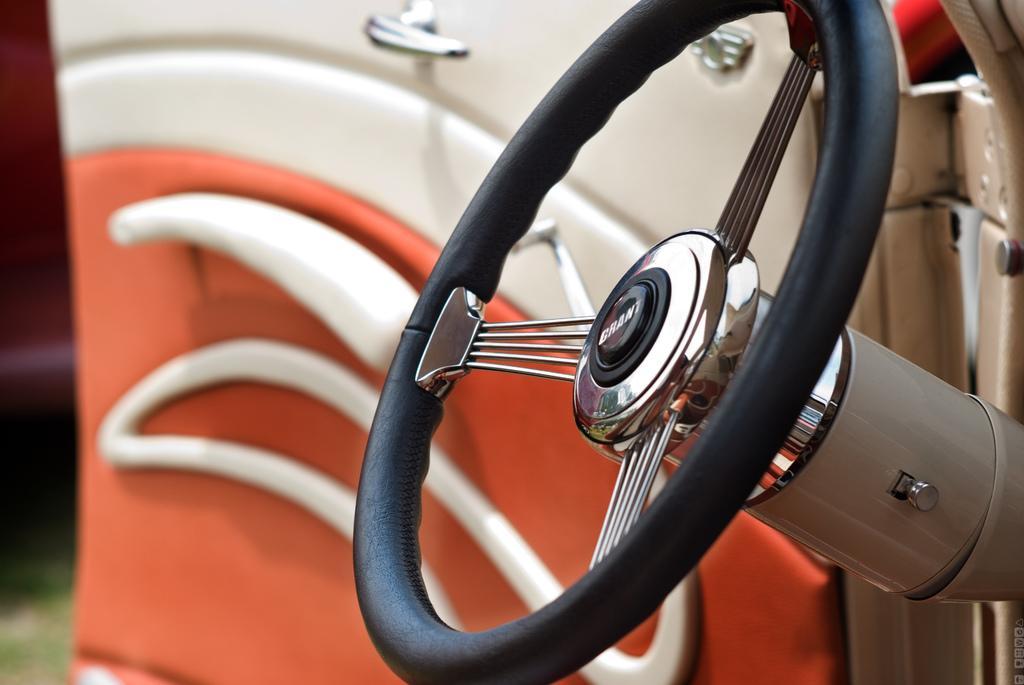Can you describe this image briefly? This picture contains the steering wheel of the car. Beside that, we see the door of the car which is in white and red color. 